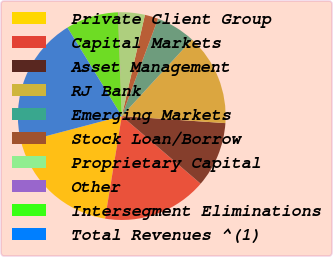<chart> <loc_0><loc_0><loc_500><loc_500><pie_chart><fcel>Private Client Group<fcel>Capital Markets<fcel>Asset Management<fcel>RJ Bank<fcel>Emerging Markets<fcel>Stock Loan/Borrow<fcel>Proprietary Capital<fcel>Other<fcel>Intersegment Eliminations<fcel>Total Revenues ^(1)<nl><fcel>18.32%<fcel>16.29%<fcel>10.2%<fcel>14.26%<fcel>6.14%<fcel>2.09%<fcel>4.11%<fcel>0.06%<fcel>8.17%<fcel>20.35%<nl></chart> 